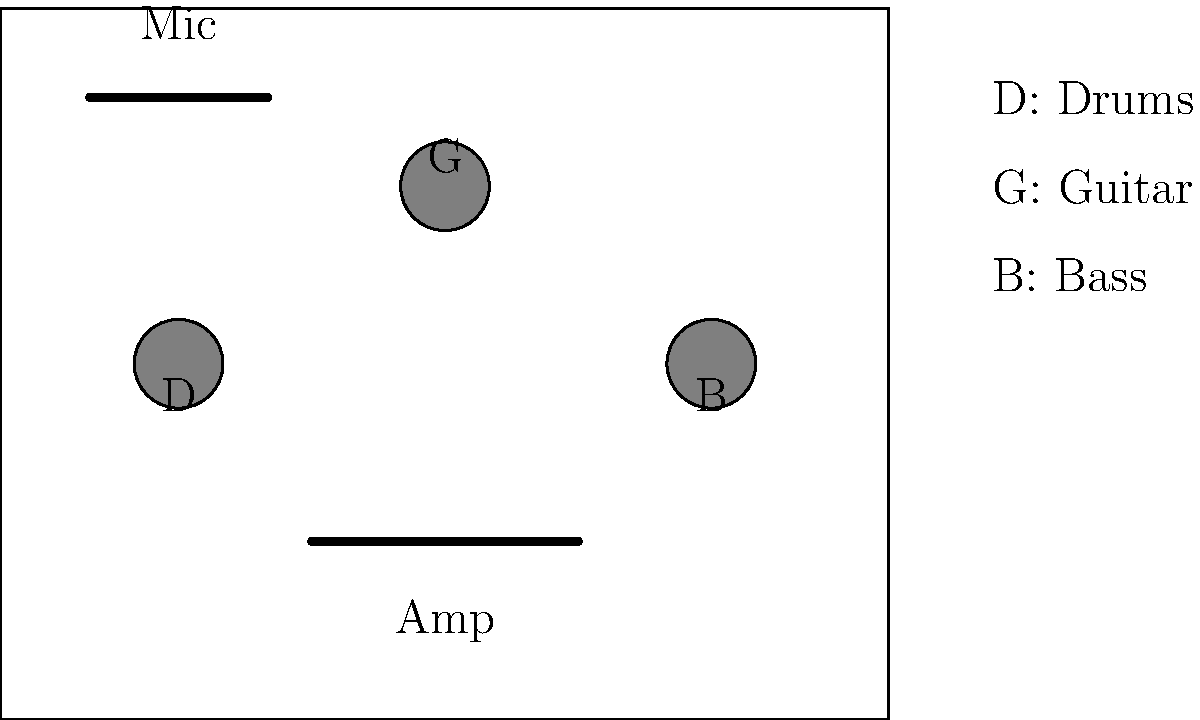In the given stage layout, which instrument placement is likely to cause the most strain on the guitarist's back during a performance, and how could this be improved to enhance ergonomics? To answer this question, we need to analyze the stage layout from an ergonomic perspective:

1. Observe the positions of the instruments:
   - Drums (D) are at the back center
   - Guitar (G) is at the front left
   - Bass (B) is at the front right
   - Amplifier is at the front center
   - Microphone is at the far left

2. Consider the guitarist's position:
   The guitarist (G) is positioned at the front left of the stage, far from the amplifier.

3. Identify the ergonomic issue:
   The guitarist will need to frequently turn around to adjust the amplifier settings, which can cause back strain over time.

4. Ergonomic principle:
   Equipment that requires frequent interaction should be placed within easy reach to minimize repetitive twisting or stretching movements.

5. Improvement suggestion:
   Move the amplifier closer to the guitarist's position, preferably to their left or right side within arm's reach. This will reduce the need for turning and bending, thus minimizing back strain.

6. Additional benefits:
   - Improved access to amplifier controls during performance
   - Reduced risk of tripping over cables
   - Better overall flow on stage
Answer: Move amplifier closer to guitarist 